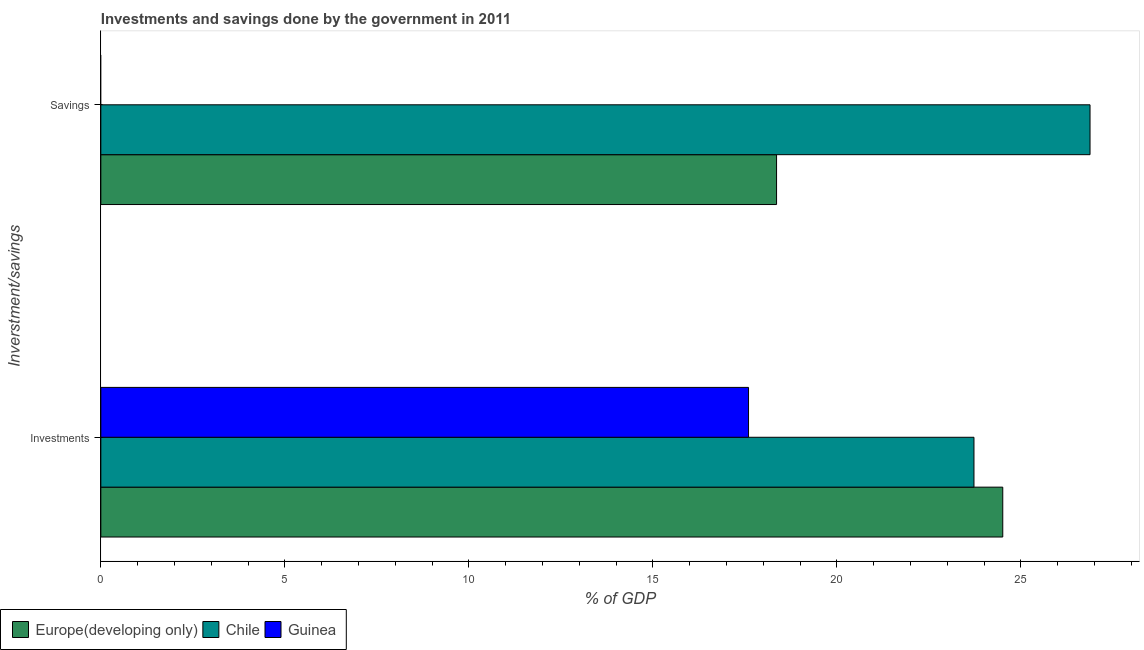How many groups of bars are there?
Offer a terse response. 2. What is the label of the 2nd group of bars from the top?
Keep it short and to the point. Investments. What is the savings of government in Europe(developing only)?
Provide a succinct answer. 18.36. Across all countries, what is the maximum investments of government?
Your response must be concise. 24.51. Across all countries, what is the minimum investments of government?
Offer a very short reply. 17.6. In which country was the investments of government maximum?
Your answer should be compact. Europe(developing only). What is the total savings of government in the graph?
Your response must be concise. 45.24. What is the difference between the investments of government in Chile and that in Europe(developing only)?
Ensure brevity in your answer.  -0.78. What is the difference between the investments of government in Chile and the savings of government in Guinea?
Your answer should be compact. 23.73. What is the average savings of government per country?
Keep it short and to the point. 15.08. What is the difference between the savings of government and investments of government in Europe(developing only)?
Your response must be concise. -6.15. What is the ratio of the investments of government in Europe(developing only) to that in Guinea?
Make the answer very short. 1.39. In how many countries, is the savings of government greater than the average savings of government taken over all countries?
Provide a succinct answer. 2. Are all the bars in the graph horizontal?
Your answer should be compact. Yes. Where does the legend appear in the graph?
Offer a very short reply. Bottom left. What is the title of the graph?
Keep it short and to the point. Investments and savings done by the government in 2011. What is the label or title of the X-axis?
Ensure brevity in your answer.  % of GDP. What is the label or title of the Y-axis?
Make the answer very short. Inverstment/savings. What is the % of GDP of Europe(developing only) in Investments?
Keep it short and to the point. 24.51. What is the % of GDP of Chile in Investments?
Make the answer very short. 23.73. What is the % of GDP of Guinea in Investments?
Give a very brief answer. 17.6. What is the % of GDP in Europe(developing only) in Savings?
Your answer should be compact. 18.36. What is the % of GDP of Chile in Savings?
Your answer should be very brief. 26.88. Across all Inverstment/savings, what is the maximum % of GDP of Europe(developing only)?
Make the answer very short. 24.51. Across all Inverstment/savings, what is the maximum % of GDP in Chile?
Provide a short and direct response. 26.88. Across all Inverstment/savings, what is the maximum % of GDP of Guinea?
Ensure brevity in your answer.  17.6. Across all Inverstment/savings, what is the minimum % of GDP of Europe(developing only)?
Ensure brevity in your answer.  18.36. Across all Inverstment/savings, what is the minimum % of GDP of Chile?
Make the answer very short. 23.73. What is the total % of GDP of Europe(developing only) in the graph?
Ensure brevity in your answer.  42.87. What is the total % of GDP in Chile in the graph?
Your response must be concise. 50.61. What is the total % of GDP in Guinea in the graph?
Your answer should be very brief. 17.6. What is the difference between the % of GDP of Europe(developing only) in Investments and that in Savings?
Offer a very short reply. 6.15. What is the difference between the % of GDP of Chile in Investments and that in Savings?
Offer a terse response. -3.15. What is the difference between the % of GDP of Europe(developing only) in Investments and the % of GDP of Chile in Savings?
Give a very brief answer. -2.37. What is the average % of GDP of Europe(developing only) per Inverstment/savings?
Your response must be concise. 21.44. What is the average % of GDP in Chile per Inverstment/savings?
Provide a succinct answer. 25.3. What is the average % of GDP of Guinea per Inverstment/savings?
Your answer should be compact. 8.8. What is the difference between the % of GDP in Europe(developing only) and % of GDP in Chile in Investments?
Make the answer very short. 0.78. What is the difference between the % of GDP in Europe(developing only) and % of GDP in Guinea in Investments?
Give a very brief answer. 6.91. What is the difference between the % of GDP of Chile and % of GDP of Guinea in Investments?
Give a very brief answer. 6.13. What is the difference between the % of GDP of Europe(developing only) and % of GDP of Chile in Savings?
Offer a terse response. -8.52. What is the ratio of the % of GDP in Europe(developing only) in Investments to that in Savings?
Your response must be concise. 1.33. What is the ratio of the % of GDP in Chile in Investments to that in Savings?
Offer a terse response. 0.88. What is the difference between the highest and the second highest % of GDP in Europe(developing only)?
Offer a terse response. 6.15. What is the difference between the highest and the second highest % of GDP in Chile?
Offer a very short reply. 3.15. What is the difference between the highest and the lowest % of GDP of Europe(developing only)?
Provide a short and direct response. 6.15. What is the difference between the highest and the lowest % of GDP of Chile?
Your response must be concise. 3.15. What is the difference between the highest and the lowest % of GDP in Guinea?
Your answer should be very brief. 17.6. 